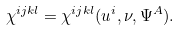Convert formula to latex. <formula><loc_0><loc_0><loc_500><loc_500>\chi ^ { i j k l } = \chi ^ { i j k l } ( u ^ { i } , \nu , \Psi ^ { A } ) .</formula> 